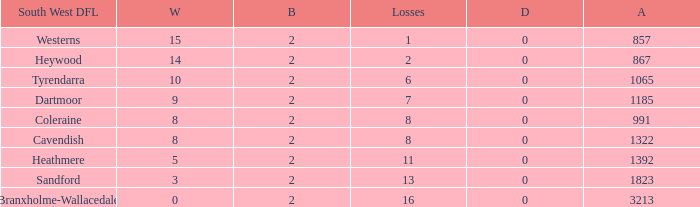How many wins have 16 losses and an Against smaller than 3213? None. 